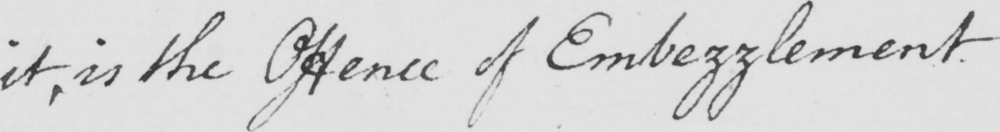Please provide the text content of this handwritten line. it , is the Offence of Embezzlement . 